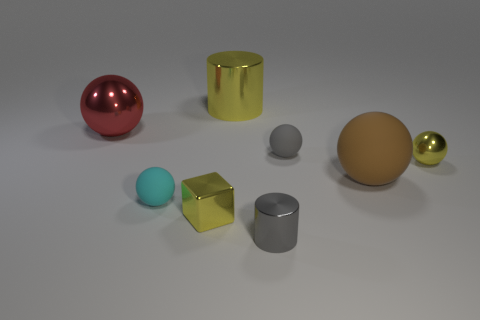Subtract all yellow cylinders. How many cylinders are left? 1 Subtract all small yellow spheres. How many spheres are left? 4 Add 1 cylinders. How many objects exist? 9 Subtract all cubes. How many objects are left? 7 Subtract 0 cyan cylinders. How many objects are left? 8 Subtract 4 spheres. How many spheres are left? 1 Subtract all red spheres. Subtract all cyan blocks. How many spheres are left? 4 Subtract all green balls. How many cyan cubes are left? 0 Subtract all large cyan rubber spheres. Subtract all tiny shiny balls. How many objects are left? 7 Add 6 tiny yellow cubes. How many tiny yellow cubes are left? 7 